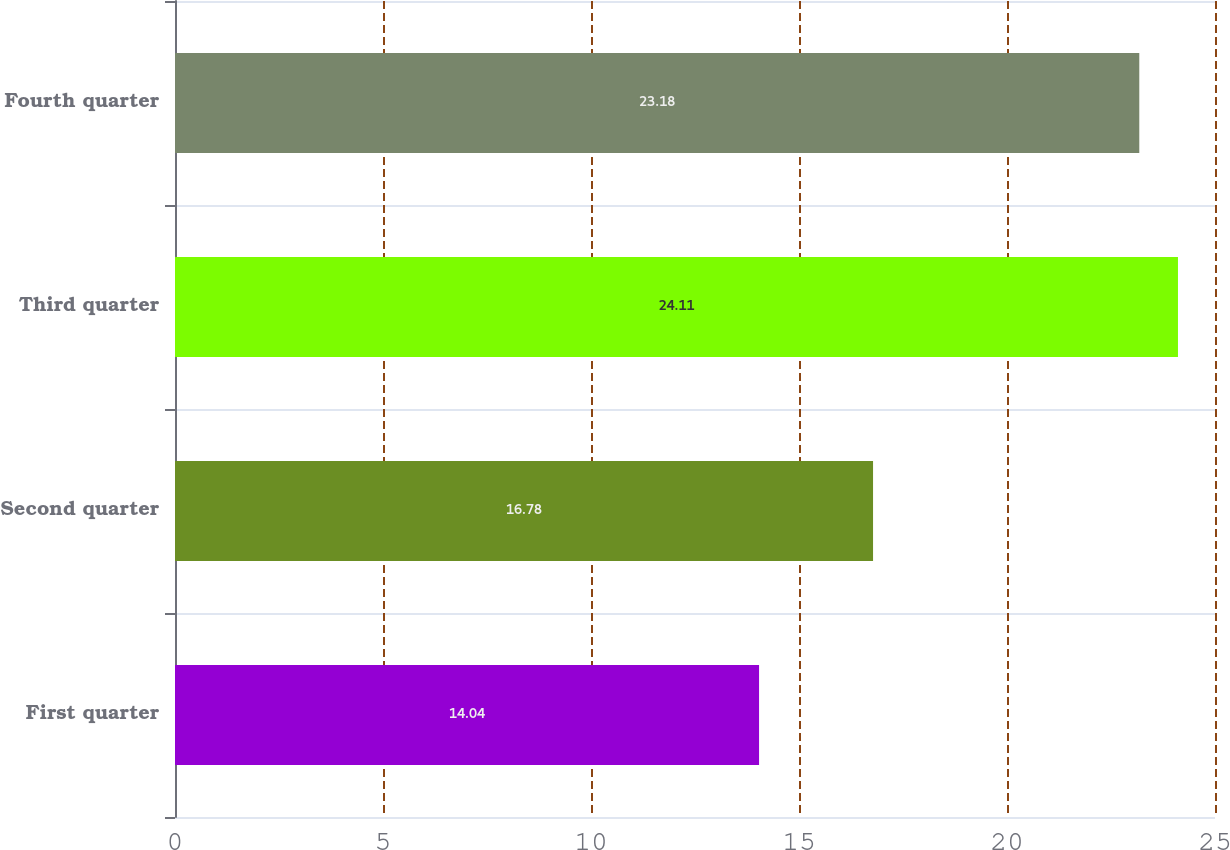Convert chart. <chart><loc_0><loc_0><loc_500><loc_500><bar_chart><fcel>First quarter<fcel>Second quarter<fcel>Third quarter<fcel>Fourth quarter<nl><fcel>14.04<fcel>16.78<fcel>24.11<fcel>23.18<nl></chart> 